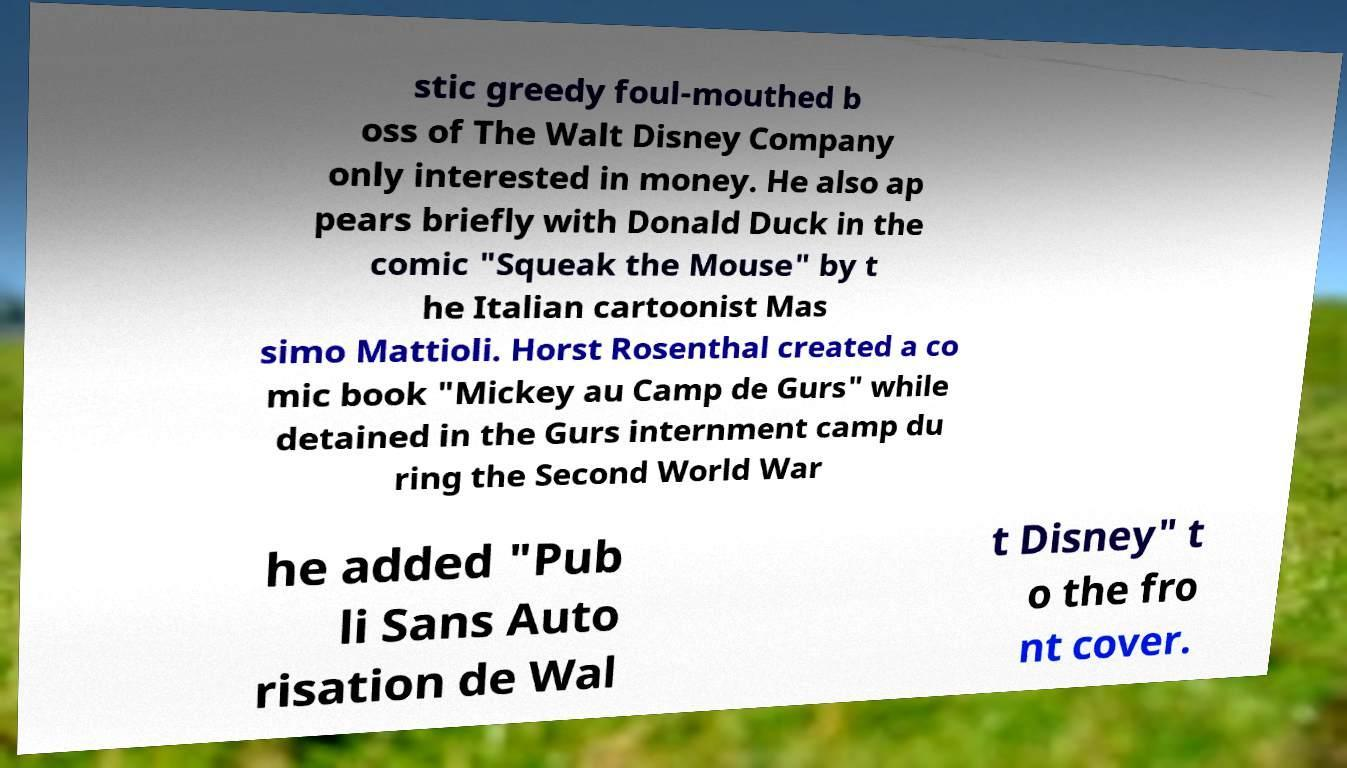Please read and relay the text visible in this image. What does it say? stic greedy foul-mouthed b oss of The Walt Disney Company only interested in money. He also ap pears briefly with Donald Duck in the comic "Squeak the Mouse" by t he Italian cartoonist Mas simo Mattioli. Horst Rosenthal created a co mic book "Mickey au Camp de Gurs" while detained in the Gurs internment camp du ring the Second World War he added "Pub li Sans Auto risation de Wal t Disney" t o the fro nt cover. 